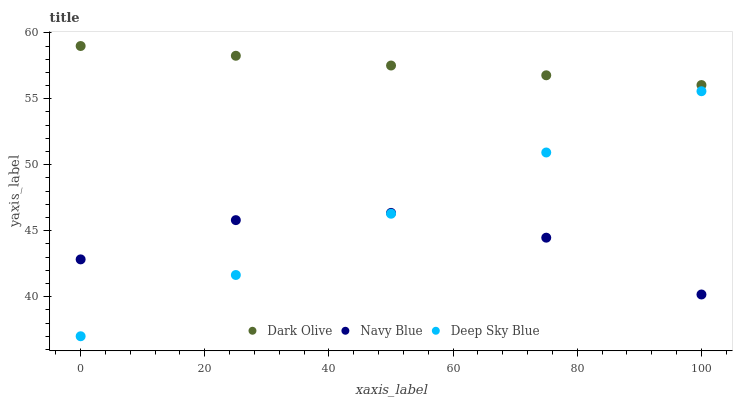Does Navy Blue have the minimum area under the curve?
Answer yes or no. Yes. Does Dark Olive have the maximum area under the curve?
Answer yes or no. Yes. Does Deep Sky Blue have the minimum area under the curve?
Answer yes or no. No. Does Deep Sky Blue have the maximum area under the curve?
Answer yes or no. No. Is Dark Olive the smoothest?
Answer yes or no. Yes. Is Navy Blue the roughest?
Answer yes or no. Yes. Is Deep Sky Blue the smoothest?
Answer yes or no. No. Is Deep Sky Blue the roughest?
Answer yes or no. No. Does Deep Sky Blue have the lowest value?
Answer yes or no. Yes. Does Dark Olive have the lowest value?
Answer yes or no. No. Does Dark Olive have the highest value?
Answer yes or no. Yes. Does Deep Sky Blue have the highest value?
Answer yes or no. No. Is Deep Sky Blue less than Dark Olive?
Answer yes or no. Yes. Is Dark Olive greater than Navy Blue?
Answer yes or no. Yes. Does Deep Sky Blue intersect Navy Blue?
Answer yes or no. Yes. Is Deep Sky Blue less than Navy Blue?
Answer yes or no. No. Is Deep Sky Blue greater than Navy Blue?
Answer yes or no. No. Does Deep Sky Blue intersect Dark Olive?
Answer yes or no. No. 